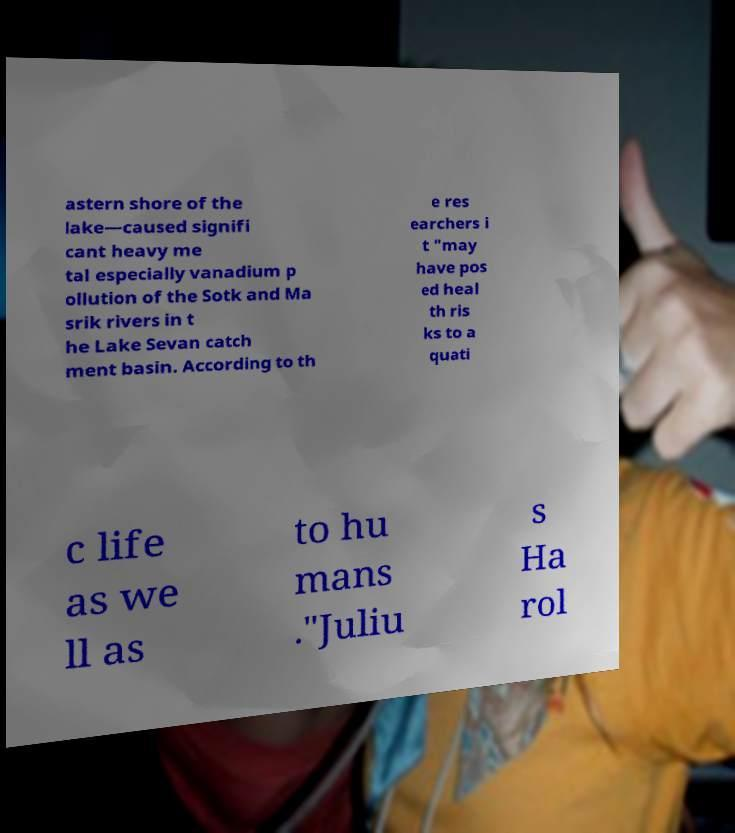Can you read and provide the text displayed in the image?This photo seems to have some interesting text. Can you extract and type it out for me? astern shore of the lake—caused signifi cant heavy me tal especially vanadium p ollution of the Sotk and Ma srik rivers in t he Lake Sevan catch ment basin. According to th e res earchers i t "may have pos ed heal th ris ks to a quati c life as we ll as to hu mans ."Juliu s Ha rol 